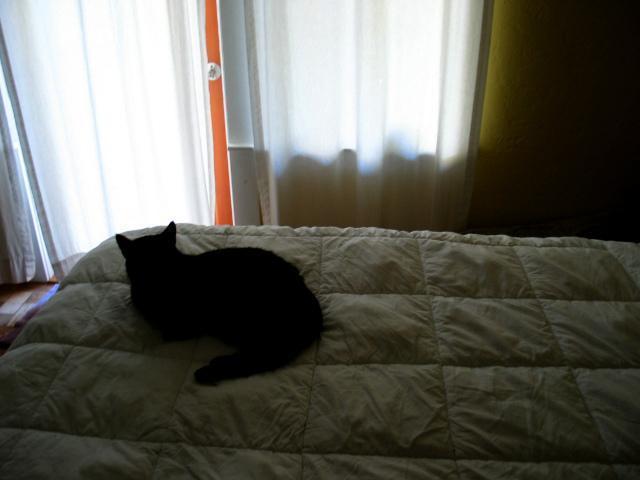How many women are wearing blue scarfs?
Give a very brief answer. 0. 